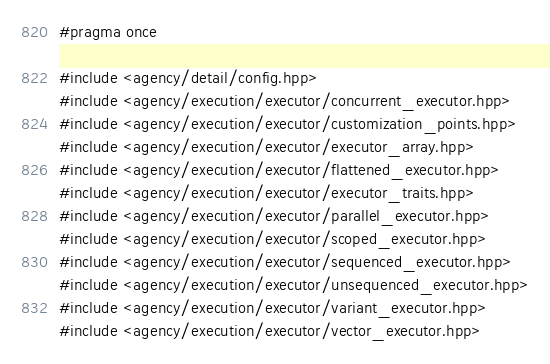Convert code to text. <code><loc_0><loc_0><loc_500><loc_500><_C++_>#pragma once

#include <agency/detail/config.hpp>
#include <agency/execution/executor/concurrent_executor.hpp>
#include <agency/execution/executor/customization_points.hpp>
#include <agency/execution/executor/executor_array.hpp>
#include <agency/execution/executor/flattened_executor.hpp>
#include <agency/execution/executor/executor_traits.hpp>
#include <agency/execution/executor/parallel_executor.hpp>
#include <agency/execution/executor/scoped_executor.hpp>
#include <agency/execution/executor/sequenced_executor.hpp>
#include <agency/execution/executor/unsequenced_executor.hpp>
#include <agency/execution/executor/variant_executor.hpp>
#include <agency/execution/executor/vector_executor.hpp>

</code> 